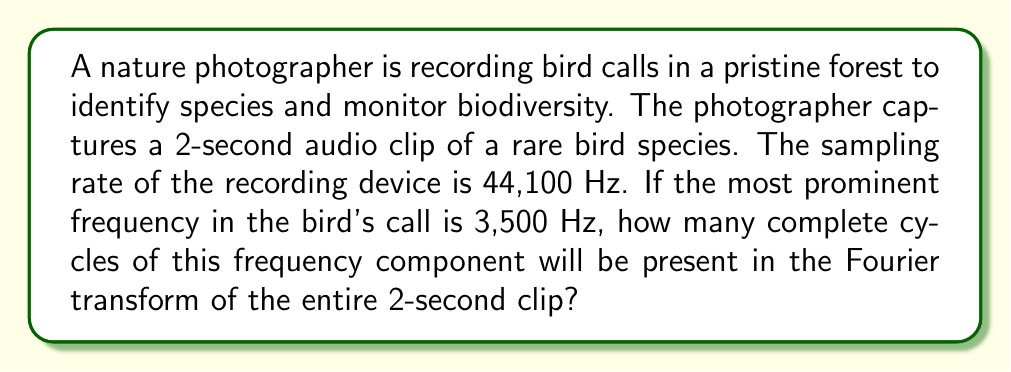Show me your answer to this math problem. To solve this problem, we need to understand the relationship between the time domain and frequency domain representation of a signal, which is given by the Fourier transform. Let's break it down step by step:

1) First, we need to understand what the Fourier transform does. It converts a time-domain signal into its frequency domain representation.

2) The resolution of the Fourier transform is inversely proportional to the length of the time-domain signal. The frequency resolution $\Delta f$ is given by:

   $$\Delta f = \frac{1}{T}$$

   where $T$ is the total duration of the signal.

3) In this case, $T = 2$ seconds. So the frequency resolution is:

   $$\Delta f = \frac{1}{2} = 0.5 \text{ Hz}$$

4) This means that in the Fourier transform, frequencies will be represented in steps of 0.5 Hz.

5) Now, we need to determine how many of these 0.5 Hz steps are in 3,500 Hz:

   $$\text{Number of steps} = \frac{3500 \text{ Hz}}{0.5 \text{ Hz/step}} = 7000 \text{ steps}$$

6) Each of these steps represents one complete cycle in the Fourier transform.

Therefore, there will be 7000 complete cycles of the 3,500 Hz frequency component in the Fourier transform of the 2-second clip.

Note: The sampling rate (44,100 Hz) is not directly used in this calculation, but it's important to ensure that it's at least twice the highest frequency we're interested in (Nyquist criterion), which it is in this case.
Answer: 7000 cycles 